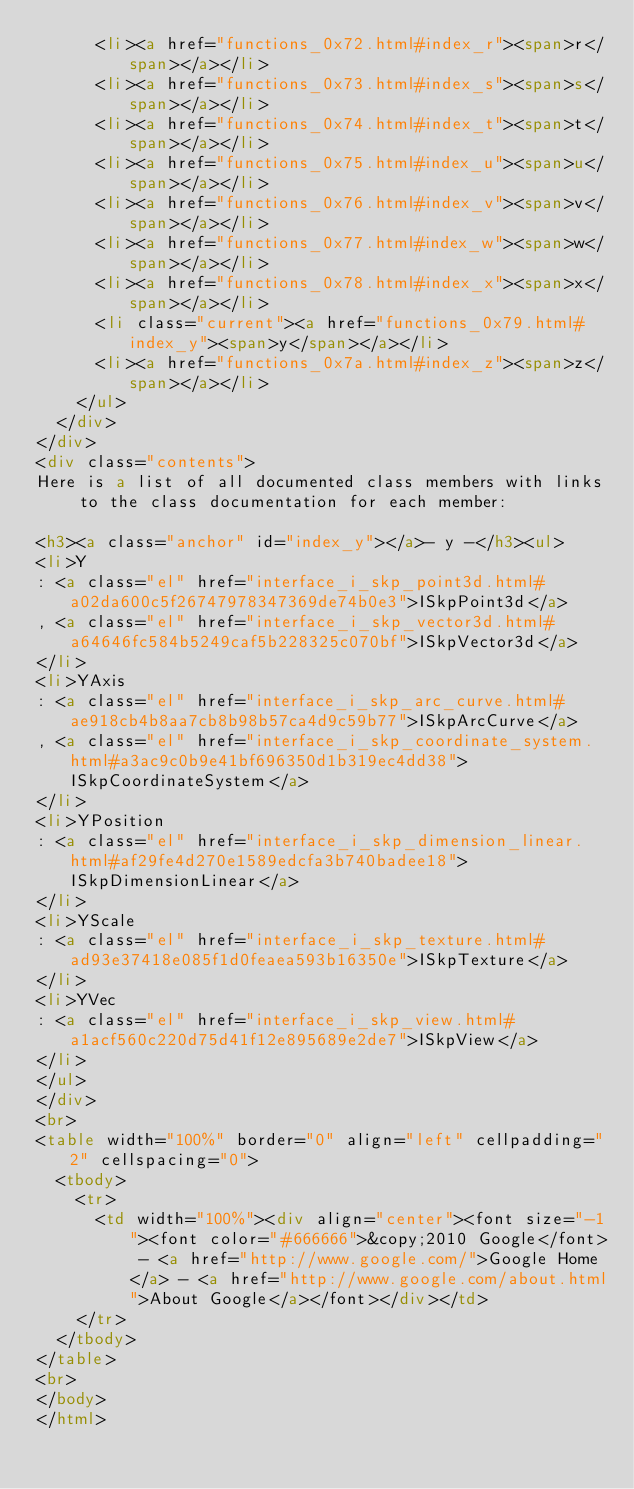<code> <loc_0><loc_0><loc_500><loc_500><_HTML_>      <li><a href="functions_0x72.html#index_r"><span>r</span></a></li>
      <li><a href="functions_0x73.html#index_s"><span>s</span></a></li>
      <li><a href="functions_0x74.html#index_t"><span>t</span></a></li>
      <li><a href="functions_0x75.html#index_u"><span>u</span></a></li>
      <li><a href="functions_0x76.html#index_v"><span>v</span></a></li>
      <li><a href="functions_0x77.html#index_w"><span>w</span></a></li>
      <li><a href="functions_0x78.html#index_x"><span>x</span></a></li>
      <li class="current"><a href="functions_0x79.html#index_y"><span>y</span></a></li>
      <li><a href="functions_0x7a.html#index_z"><span>z</span></a></li>
    </ul>
  </div>
</div>
<div class="contents">
Here is a list of all documented class members with links to the class documentation for each member:

<h3><a class="anchor" id="index_y"></a>- y -</h3><ul>
<li>Y
: <a class="el" href="interface_i_skp_point3d.html#a02da600c5f26747978347369de74b0e3">ISkpPoint3d</a>
, <a class="el" href="interface_i_skp_vector3d.html#a64646fc584b5249caf5b228325c070bf">ISkpVector3d</a>
</li>
<li>YAxis
: <a class="el" href="interface_i_skp_arc_curve.html#ae918cb4b8aa7cb8b98b57ca4d9c59b77">ISkpArcCurve</a>
, <a class="el" href="interface_i_skp_coordinate_system.html#a3ac9c0b9e41bf696350d1b319ec4dd38">ISkpCoordinateSystem</a>
</li>
<li>YPosition
: <a class="el" href="interface_i_skp_dimension_linear.html#af29fe4d270e1589edcfa3b740badee18">ISkpDimensionLinear</a>
</li>
<li>YScale
: <a class="el" href="interface_i_skp_texture.html#ad93e37418e085f1d0feaea593b16350e">ISkpTexture</a>
</li>
<li>YVec
: <a class="el" href="interface_i_skp_view.html#a1acf560c220d75d41f12e895689e2de7">ISkpView</a>
</li>
</ul>
</div>
<br>
<table width="100%" border="0" align="left" cellpadding="2" cellspacing="0"> 
  <tbody> 
    <tr> 
      <td width="100%"><div align="center"><font size="-1"><font color="#666666">&copy;2010 Google</font> - <a href="http://www.google.com/">Google Home</a> - <a href="http://www.google.com/about.html">About Google</a></font></div></td> 
    </tr> 
  </tbody> 
</table> 
<br>
</body>
</html>
</code> 